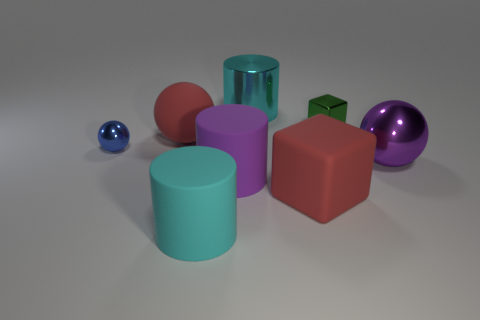What number of objects are rubber spheres right of the tiny blue ball or metallic objects that are left of the metallic cylinder?
Ensure brevity in your answer.  2. What number of other objects are the same color as the matte sphere?
Offer a terse response. 1. There is a tiny shiny thing behind the tiny metal sphere; is it the same shape as the small blue metallic object?
Provide a short and direct response. No. Is the number of big matte objects that are in front of the red matte sphere less than the number of brown metallic cylinders?
Ensure brevity in your answer.  No. Is there a small green block that has the same material as the small ball?
Your answer should be very brief. Yes. What is the material of the other thing that is the same size as the green object?
Provide a succinct answer. Metal. Is the number of cyan cylinders in front of the blue metallic sphere less than the number of cyan matte cylinders that are on the left side of the red block?
Your answer should be compact. No. What shape is the metallic thing that is both to the left of the small green object and right of the large purple rubber thing?
Ensure brevity in your answer.  Cylinder. What number of cyan shiny objects are the same shape as the big cyan matte thing?
Your response must be concise. 1. What size is the red thing that is made of the same material as the red sphere?
Make the answer very short. Large. 